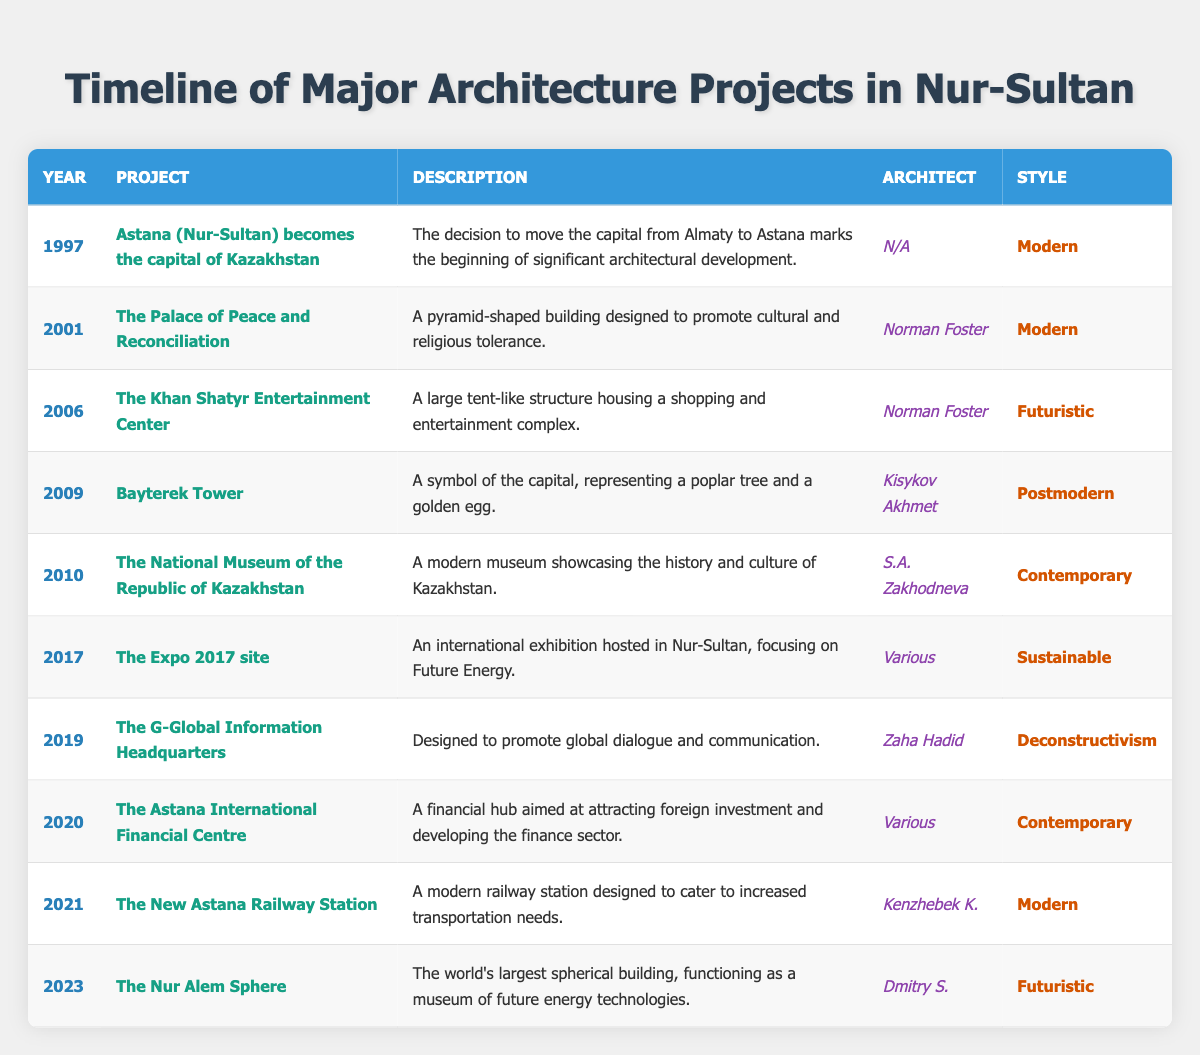What year did Astana become the capital of Kazakhstan? The table lists the event "Astana (Nur-Sultan) becomes the capital of Kazakhstan" in the year column for 1997.
Answer: 1997 Who designed the Palace of Peace and Reconciliation? According to the table, the architect for the Palace of Peace and Reconciliation is Norman Foster.
Answer: Norman Foster How many projects were completed between 2017 and 2023? The projects listed in the table from 2017 to 2023 include six projects: Expo 2017 site, G-Global Information Headquarters, Astana International Financial Centre, New Astana Railway Station, and Nur Alem Sphere, which totals to five completed projects.
Answer: 5 Is the Khan Shatyr Entertainment Center designed in a sustainable style? The style of the Khan Shatyr Entertainment Center is categorized as "Futuristic," not "Sustainable," thus the statement is false.
Answer: No What is the difference in years between the completion of Bayterek Tower and the Nur Alem Sphere? Bayterek Tower was completed in 2009 and the Nur Alem Sphere in 2023. The difference in years is calculated as 2023 - 2009 = 14 years.
Answer: 14 Which architectural style has the highest representation among the listed projects? By counting the styles in the table, the Modern style appears four times (for Astana, Palace of Peace, New Railway Station) compared to the Futuristic and Contemporary styles, suggesting Modern is the most common.
Answer: Modern What is the latest project mentioned in the timeline? The most recent project listed in the timeline is the Nur Alem Sphere, completed in 2023, indicating it is the latest project.
Answer: Nur Alem Sphere Was the National Museum of the Republic of Kazakhstan the first project after Astana became the capital? No, it was completed in 2010, and several projects took place between 1997 and 2010, such as the Palace of Peace and Reconciliation and Khan Shatyr. Thus, it wasn't the first.
Answer: No 